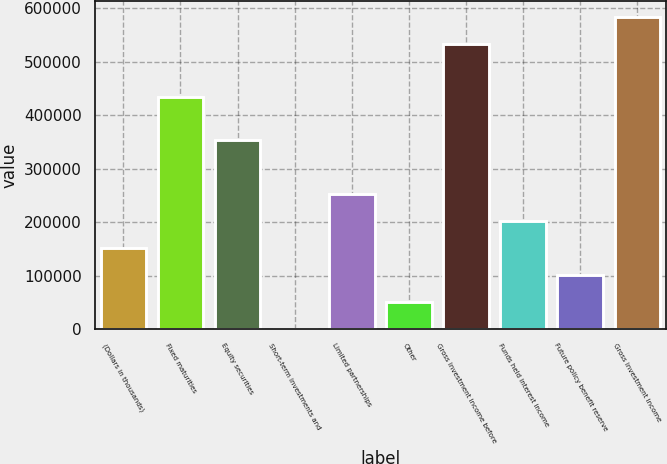<chart> <loc_0><loc_0><loc_500><loc_500><bar_chart><fcel>(Dollars in thousands)<fcel>Fixed maturities<fcel>Equity securities<fcel>Short-term investments and<fcel>Limited partnerships<fcel>Other<fcel>Gross investment income before<fcel>Funds held interest income<fcel>Future policy benefit reserve<fcel>Gross investment income<nl><fcel>152368<fcel>433097<fcel>353891<fcel>1225<fcel>253130<fcel>51605.9<fcel>533859<fcel>202749<fcel>101987<fcel>584240<nl></chart> 